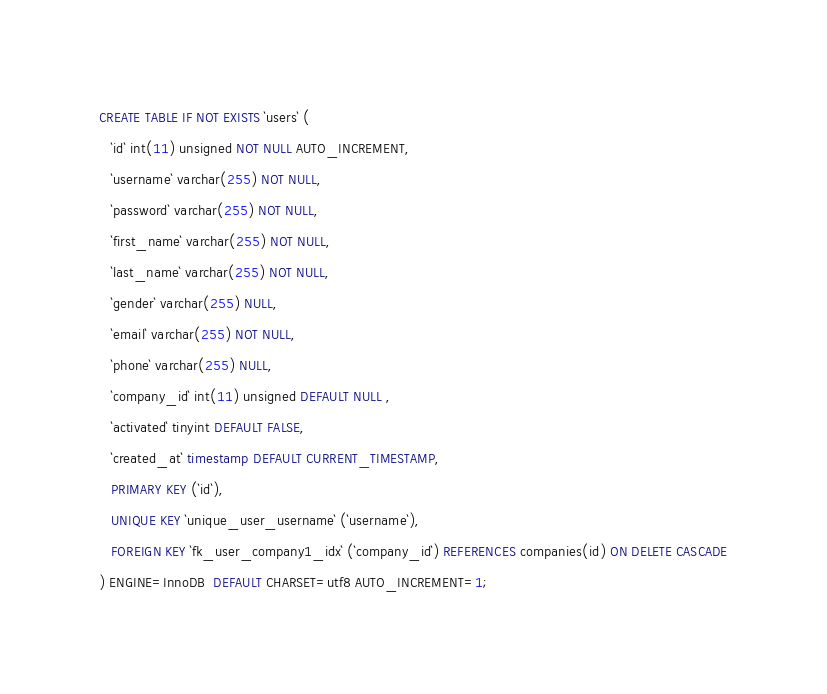<code> <loc_0><loc_0><loc_500><loc_500><_SQL_>CREATE TABLE IF NOT EXISTS `users` (
   `id` int(11) unsigned NOT NULL AUTO_INCREMENT,
   `username` varchar(255) NOT NULL,
   `password` varchar(255) NOT NULL,
   `first_name` varchar(255) NOT NULL,
   `last_name` varchar(255) NOT NULL,
   `gender` varchar(255) NULL,
   `email` varchar(255) NOT NULL,
   `phone` varchar(255) NULL,
   `company_id` int(11) unsigned DEFAULT NULL ,
   `activated` tinyint DEFAULT FALSE,
   `created_at` timestamp DEFAULT CURRENT_TIMESTAMP,
   PRIMARY KEY (`id`),
   UNIQUE KEY `unique_user_username` (`username`),
   FOREIGN KEY `fk_user_company1_idx` (`company_id`) REFERENCES companies(id) ON DELETE CASCADE
) ENGINE=InnoDB  DEFAULT CHARSET=utf8 AUTO_INCREMENT=1;
</code> 